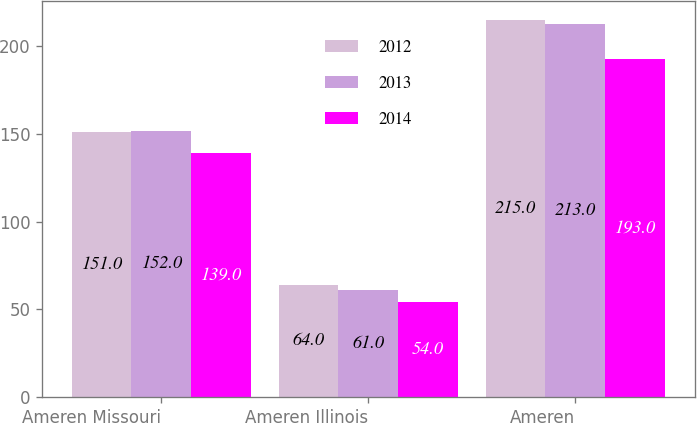<chart> <loc_0><loc_0><loc_500><loc_500><stacked_bar_chart><ecel><fcel>Ameren Missouri<fcel>Ameren Illinois<fcel>Ameren<nl><fcel>2012<fcel>151<fcel>64<fcel>215<nl><fcel>2013<fcel>152<fcel>61<fcel>213<nl><fcel>2014<fcel>139<fcel>54<fcel>193<nl></chart> 